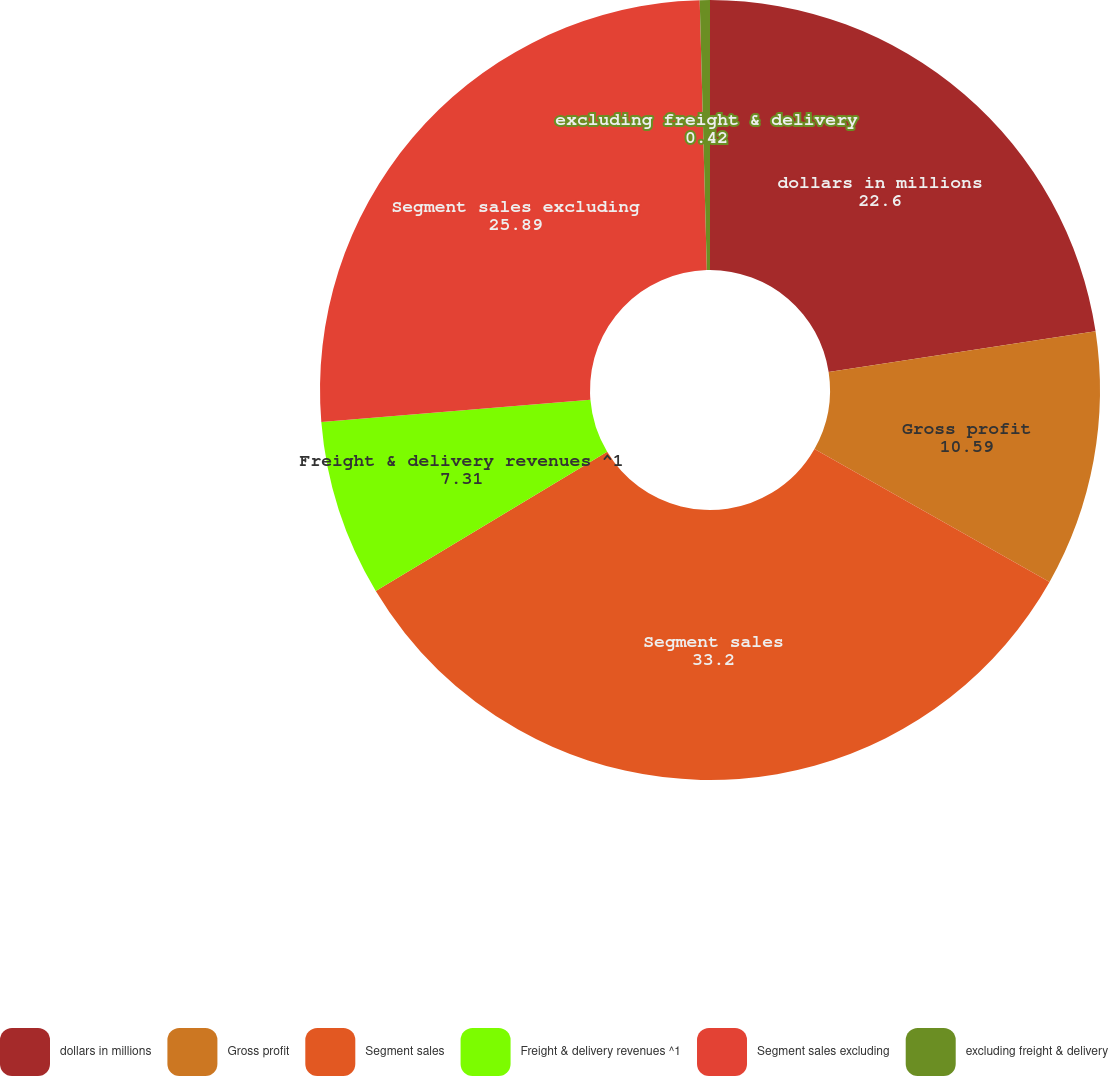Convert chart. <chart><loc_0><loc_0><loc_500><loc_500><pie_chart><fcel>dollars in millions<fcel>Gross profit<fcel>Segment sales<fcel>Freight & delivery revenues ^1<fcel>Segment sales excluding<fcel>excluding freight & delivery<nl><fcel>22.6%<fcel>10.59%<fcel>33.2%<fcel>7.31%<fcel>25.89%<fcel>0.42%<nl></chart> 